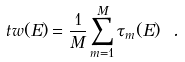Convert formula to latex. <formula><loc_0><loc_0><loc_500><loc_500>\ t w ( E ) = \frac { 1 } { M } \sum _ { m = 1 } ^ { M } \tau _ { m } ( E ) \ .</formula> 